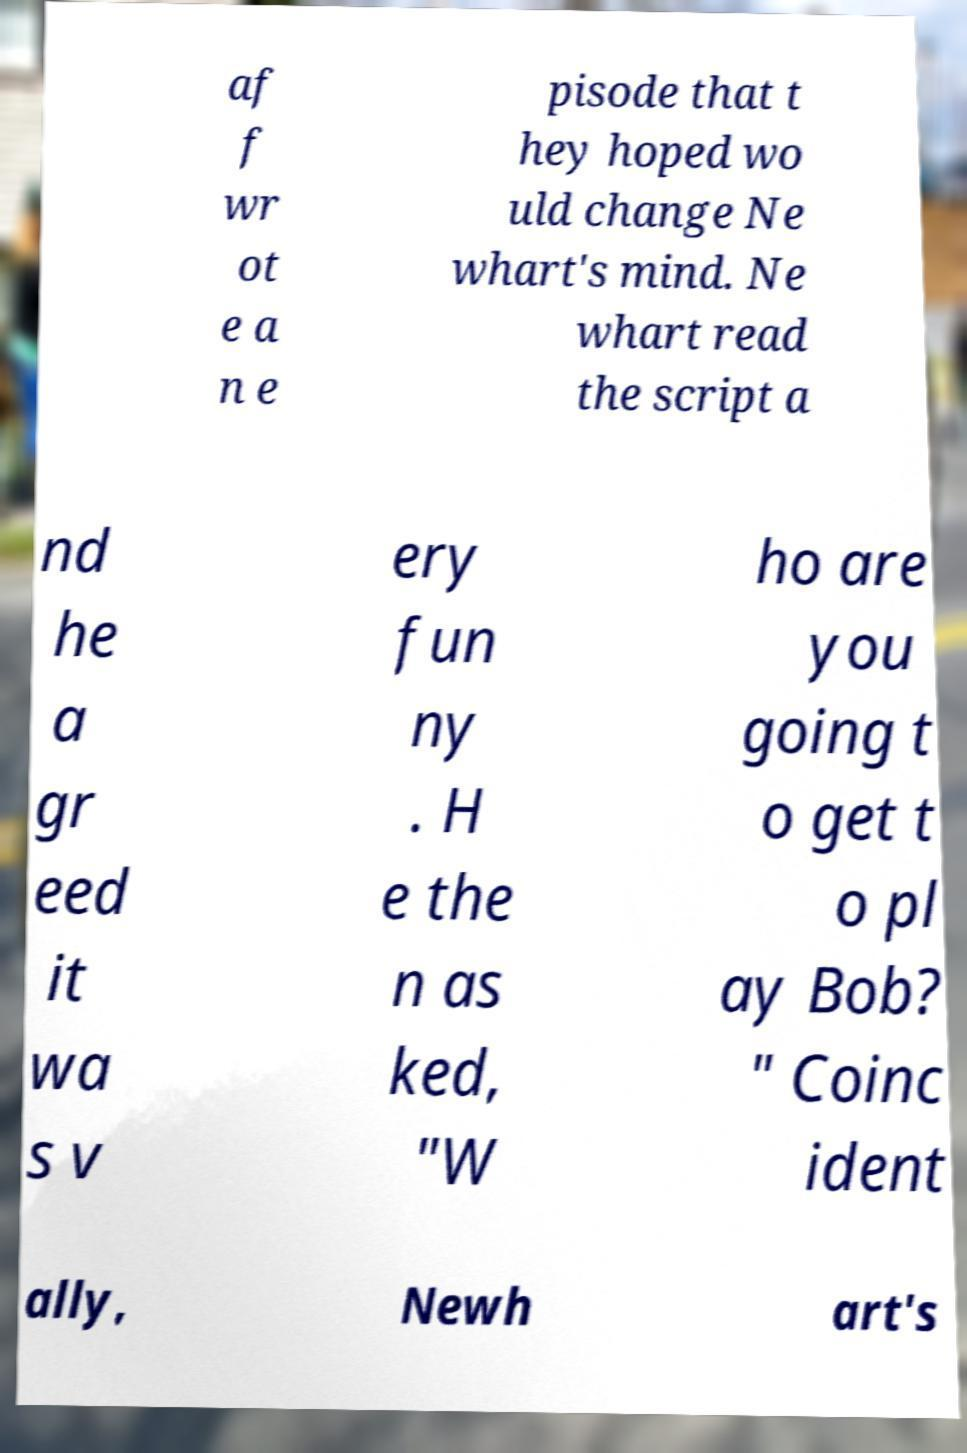What messages or text are displayed in this image? I need them in a readable, typed format. af f wr ot e a n e pisode that t hey hoped wo uld change Ne whart's mind. Ne whart read the script a nd he a gr eed it wa s v ery fun ny . H e the n as ked, "W ho are you going t o get t o pl ay Bob? " Coinc ident ally, Newh art's 